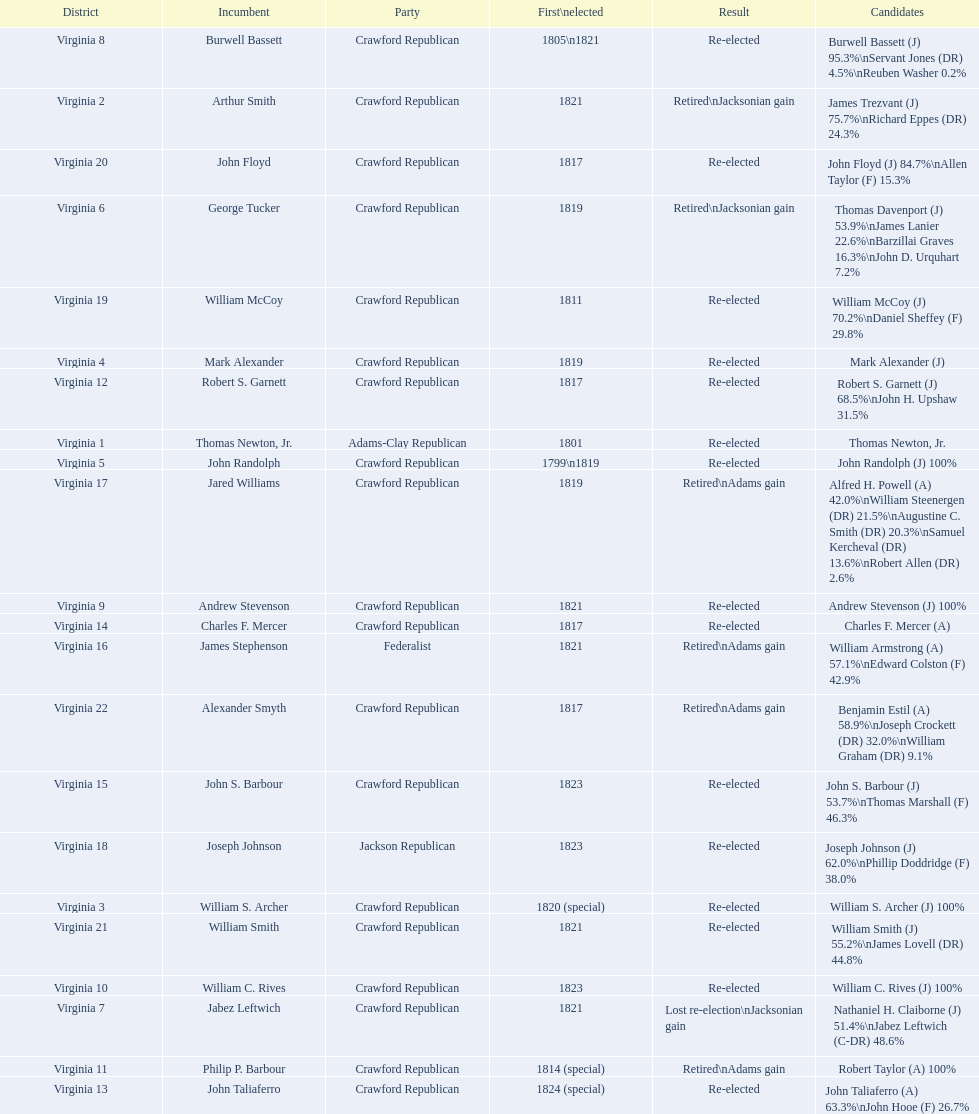Who was the next incumbent after john randolph? George Tucker. 